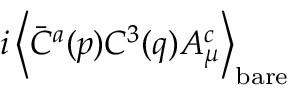<formula> <loc_0><loc_0><loc_500><loc_500>i \left < \bar { C } ^ { a } ( p ) C ^ { 3 } ( q ) A _ { \mu } ^ { c } \right > _ { b a r e }</formula> 